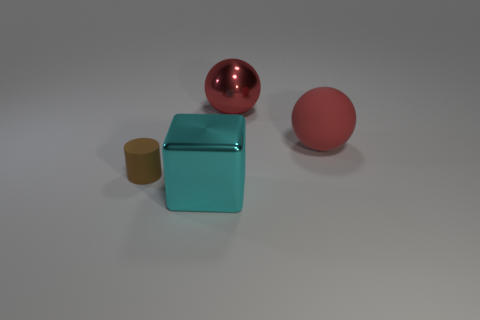How would you describe the overall composition of the scene? The composition of the scene is minimalistic and appears to be purposefully arranged. There is a balance in shapes with the spherical forms on the right-hand side and a cuboid structure on the left which, coupled with the cylinder, creates a pleasing variation of geometry. The objects are set against a neutral grey background which emphasizes their colors and forms. The lighting is soft and diffused, casting gentle shadows and contributing to the quiet, contemplative atmosphere of the setup. 